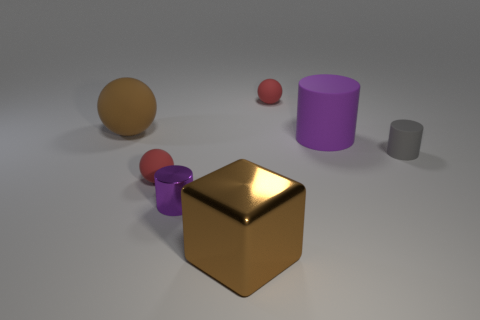Is the number of tiny matte objects behind the purple rubber cylinder less than the number of purple metallic objects?
Keep it short and to the point. No. There is a tiny red rubber thing that is in front of the gray thing; what number of small red balls are right of it?
Offer a terse response. 1. There is a matte thing that is left of the purple rubber object and to the right of the small purple object; how big is it?
Provide a short and direct response. Small. Is the big sphere made of the same material as the red sphere to the left of the large brown cube?
Your response must be concise. Yes. Are there fewer brown rubber spheres that are to the left of the big brown block than purple objects in front of the tiny purple shiny cylinder?
Offer a very short reply. No. There is a brown thing to the right of the large rubber ball; what is its material?
Provide a short and direct response. Metal. What color is the big thing that is both to the left of the purple rubber cylinder and behind the small matte cylinder?
Give a very brief answer. Brown. How many other things are there of the same color as the large metal cube?
Give a very brief answer. 1. The large rubber object that is to the right of the brown metallic object is what color?
Make the answer very short. Purple. Are there any blue metal blocks of the same size as the gray rubber object?
Make the answer very short. No. 